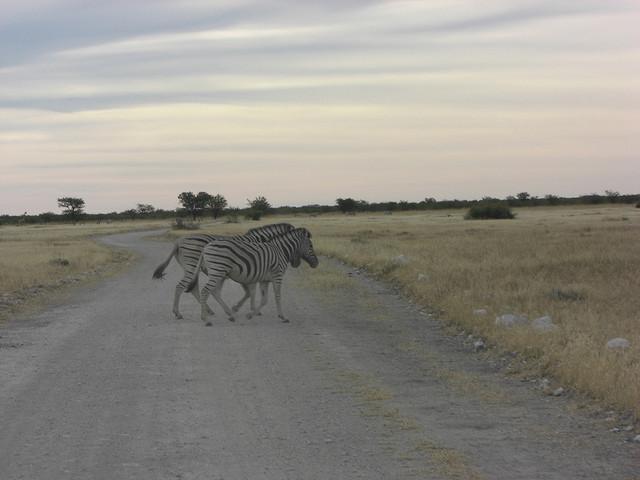How many types of animals are in the picture?
Give a very brief answer. 1. How many animals are crossing the road?
Give a very brief answer. 2. How many zebras are there?
Give a very brief answer. 2. How many zebras can be seen?
Give a very brief answer. 2. How many people rowing are wearing bright green?
Give a very brief answer. 0. 